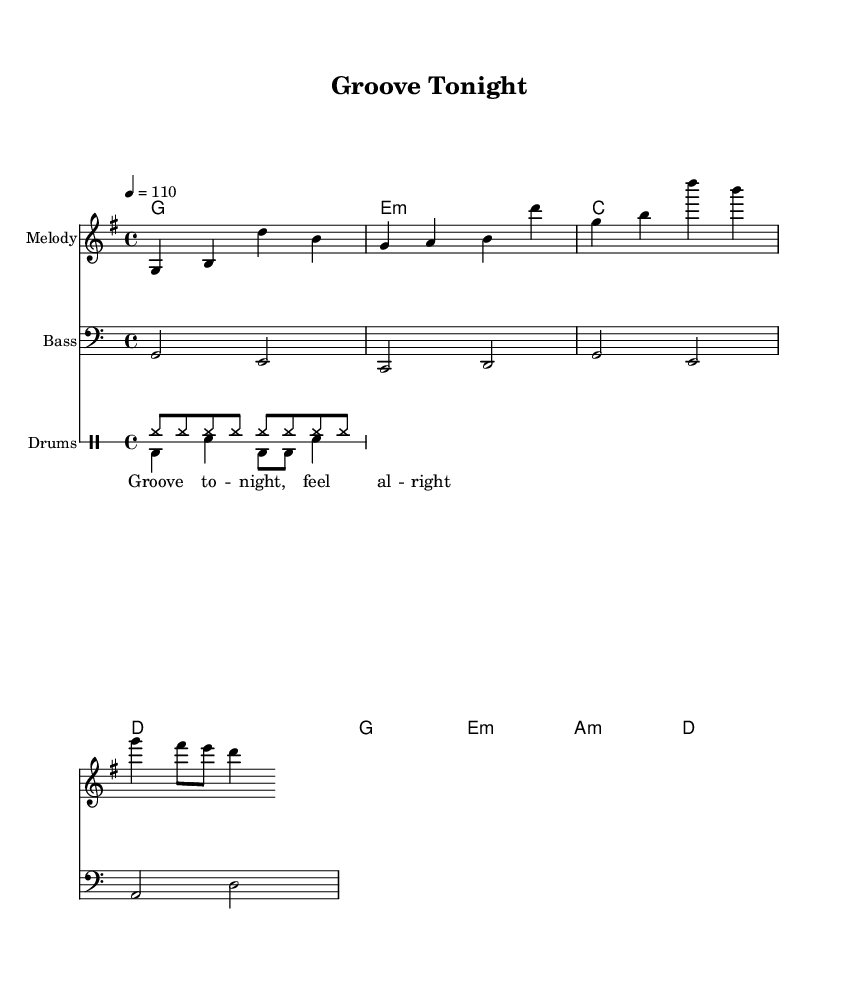What is the key signature of this music? The key signature is G major, which has one sharp (F#). This can be identified from the beginning of the piece where the key signature is indicated.
Answer: G major What is the time signature of this music? The time signature is 4/4, which means there are four beats in each measure. This is indicated at the start of the sheet music in the time signature section.
Answer: 4/4 What is the tempo marking of the piece? The tempo marking indicates a speed of 110 beats per minute. This is mentioned at the top of the score where the tempo is indicated with the speed notation.
Answer: 110 What is the first note of the melody? The first note of the melody is G. This can be seen at the beginning of the melody staff, where the note is located on the second line of the treble clef.
Answer: G How many notes are in the repeated hook lyric section? There are four notes in the repeated hook lyric section: "Groove to night, feel al right." The hook contains two lines, with each line having four corresponding melismatic notes.
Answer: Four What type of pattern is used in the drums? The drums feature a combination of hi-hat and bass drum patterns. The sheet music illustrates a steady hi-hat pattern complemented by alternating bass and snare drum patterns, typical for R&B grooves.
Answer: Hi-hat and bass drum How do the harmonies progress in the piece? The harmonies progress from G major to E minor, C major, and then D major. This sequence can be traced in the chord mode section, where each chord is played in a specific order creating a pleasant progression.
Answer: G, E minor, C, D 